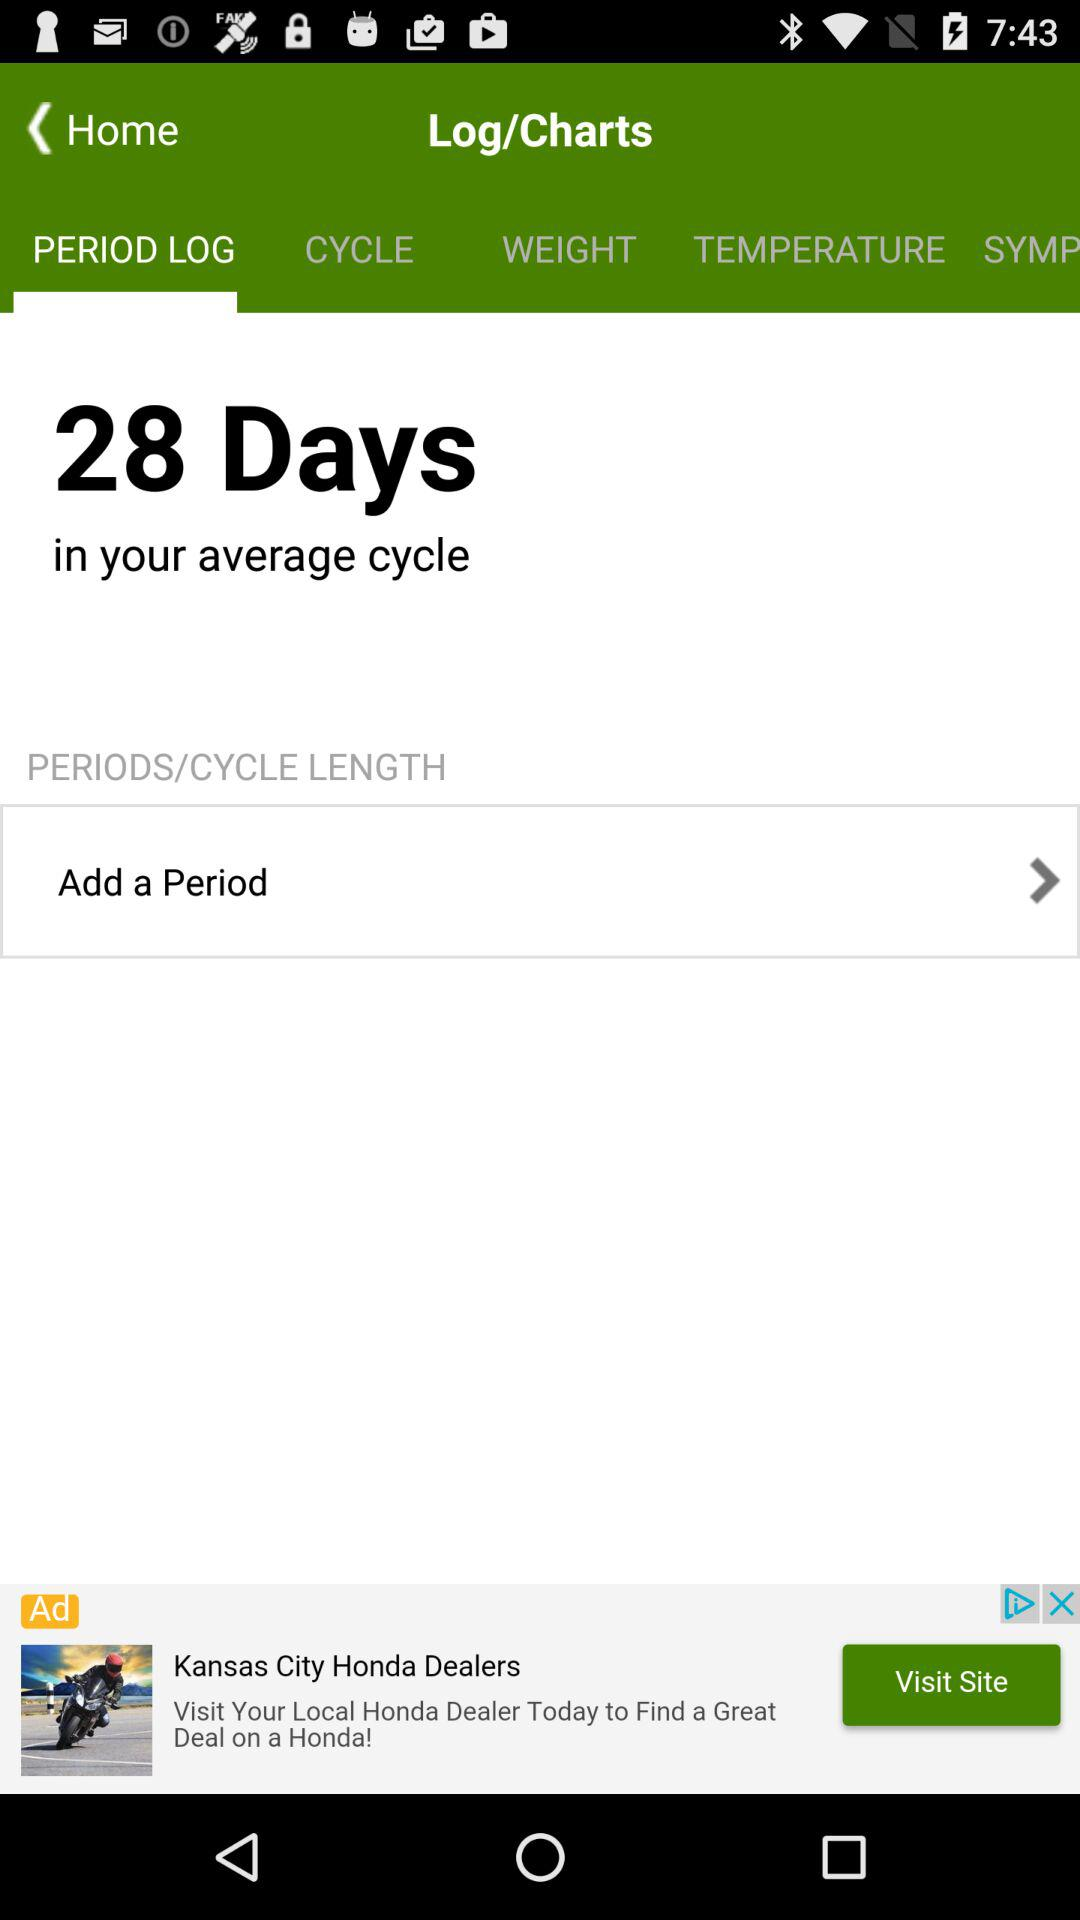Which tab is currently selected? The selected tab is "PERIOD LOG". 